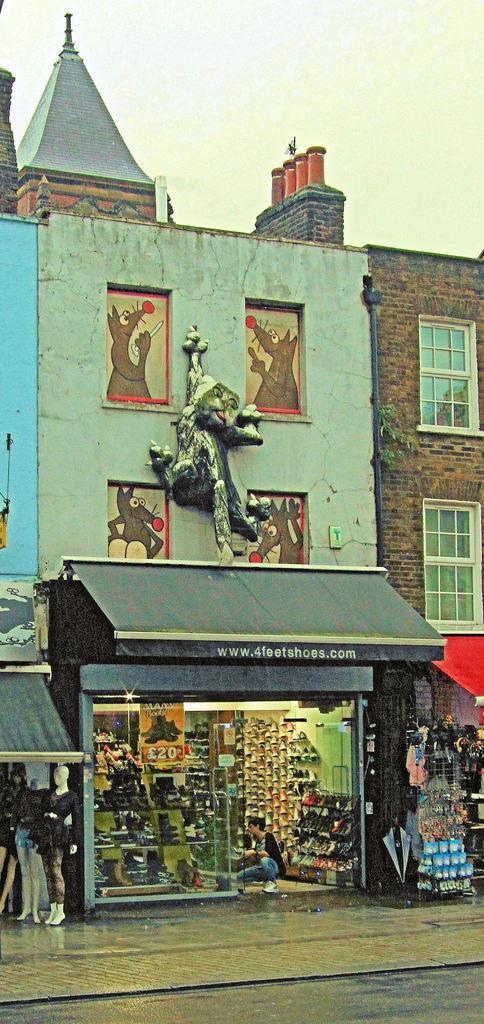Describe this image in one or two sentences. Here we can see a building and a sculpture. There are windows and this is shop. Here we can see mannequins, footwear, and a person. This is road. In the background there is sky. 